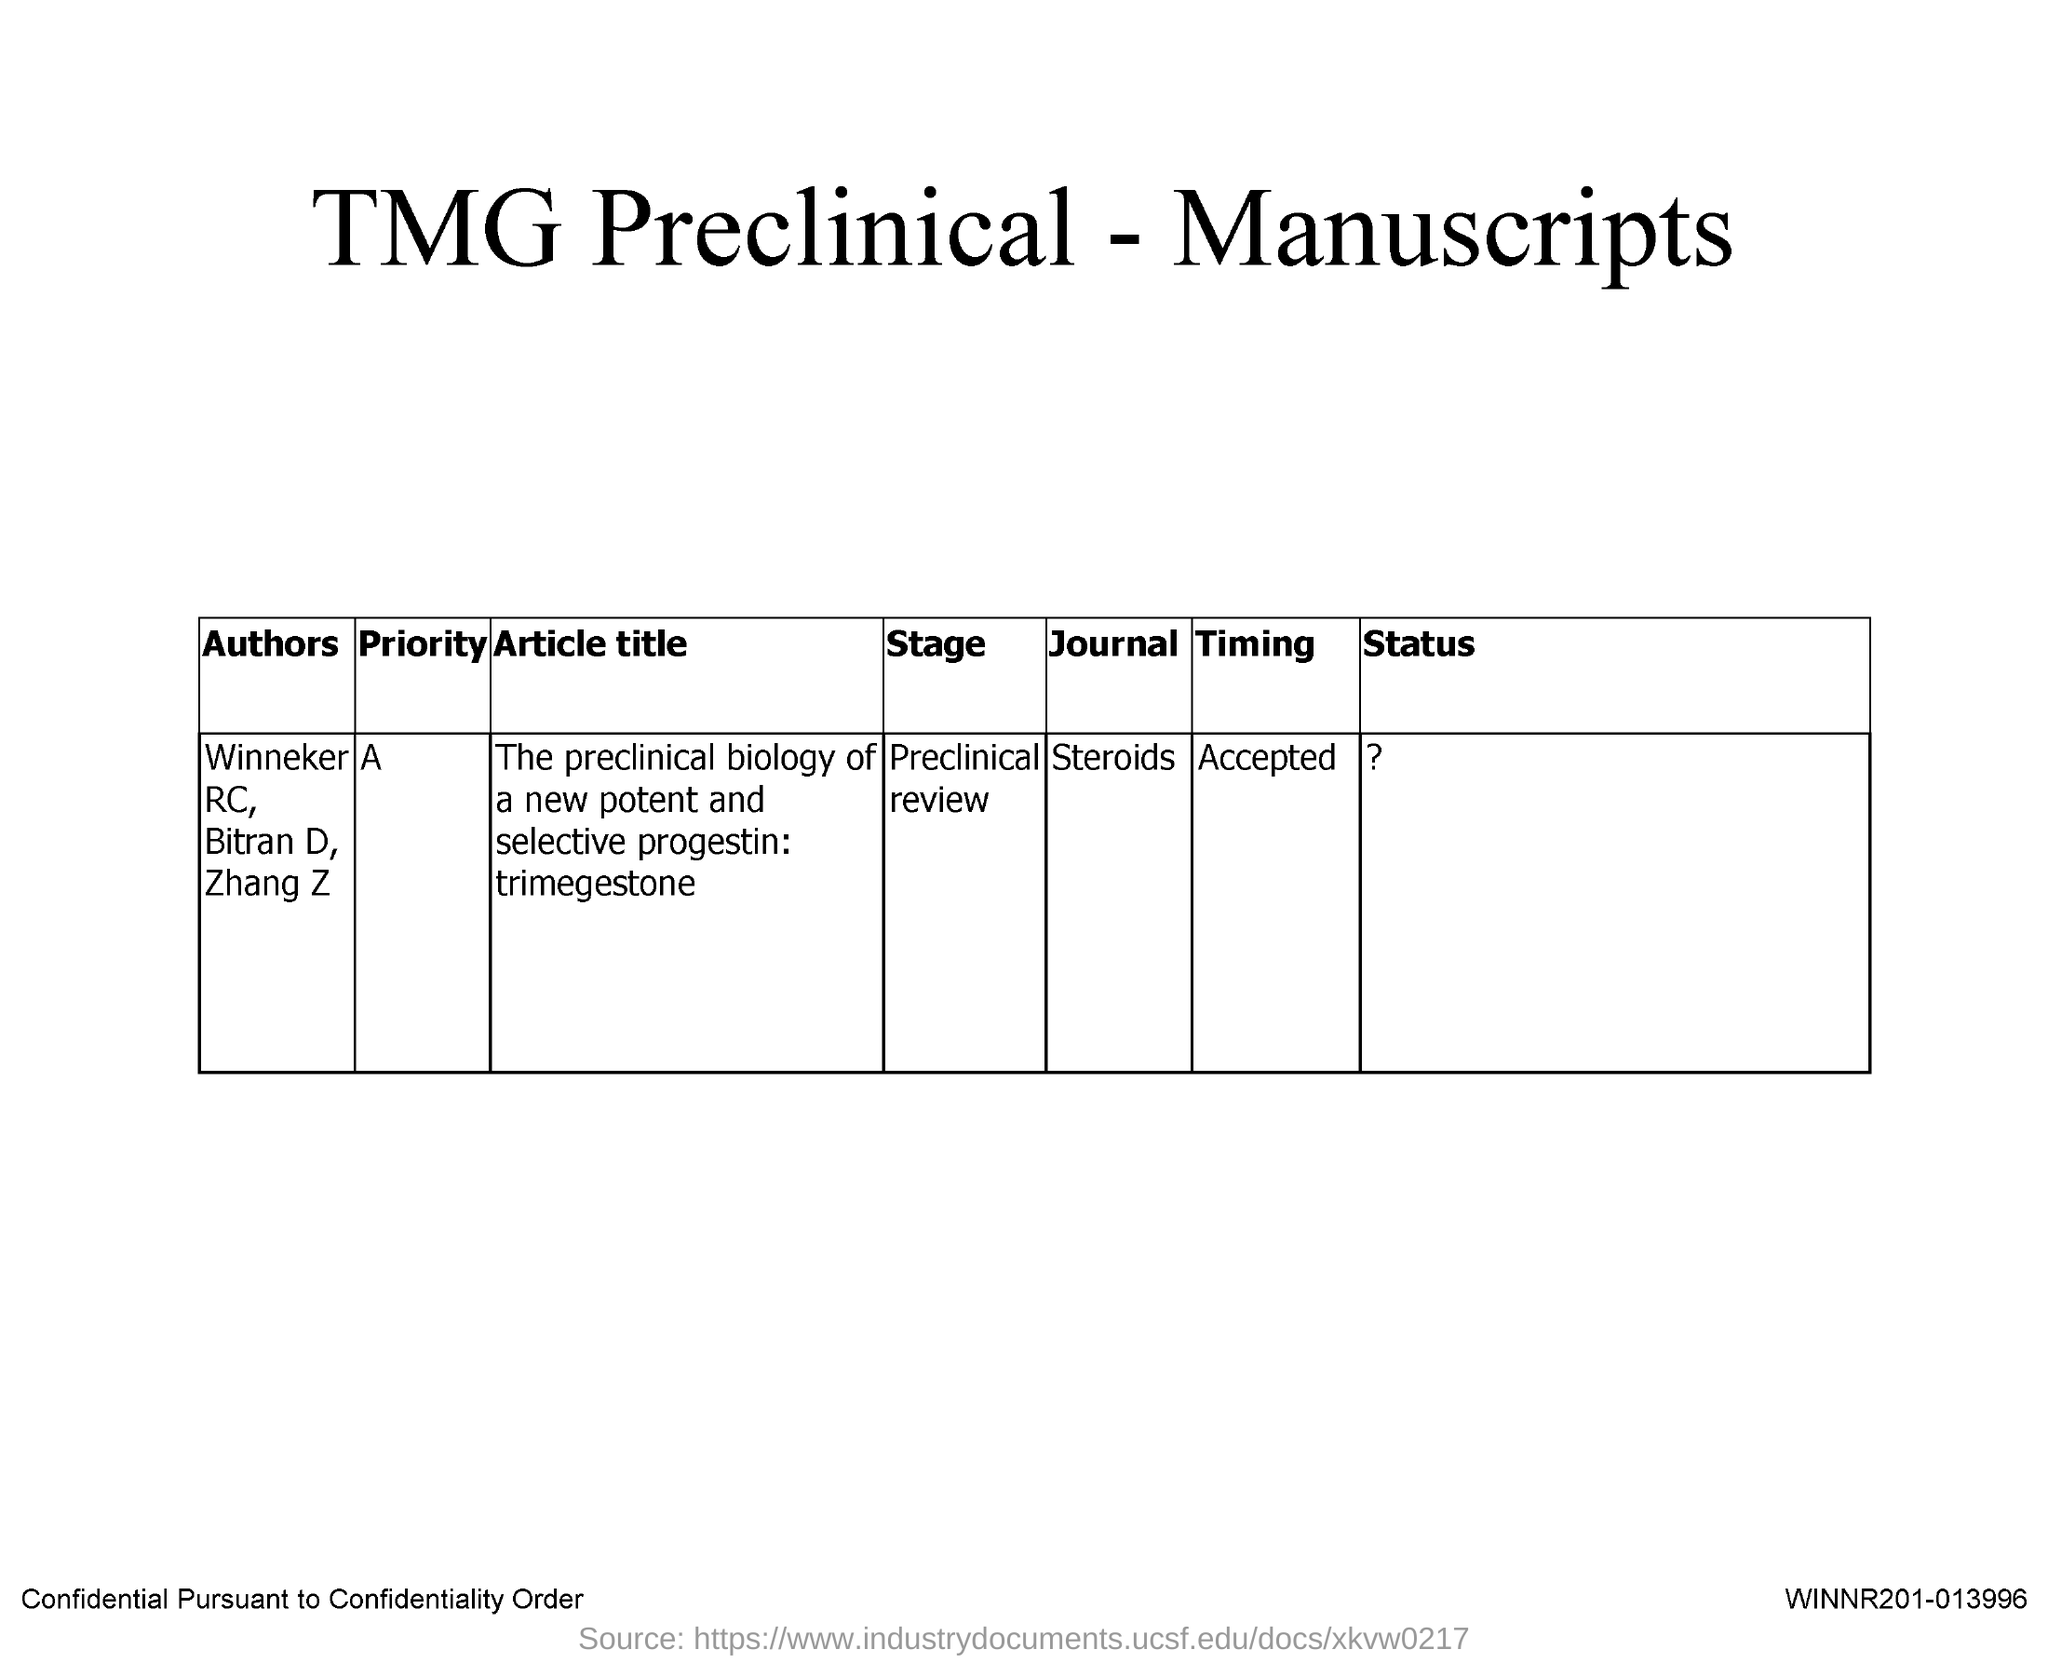What is the name of the Journal?
Ensure brevity in your answer.  Steroids. 